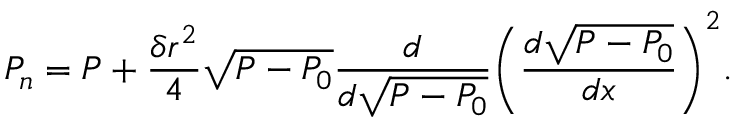Convert formula to latex. <formula><loc_0><loc_0><loc_500><loc_500>P _ { n } = P + \frac { \delta r ^ { 2 } } { 4 } \sqrt { P - P _ { 0 } } \frac { d } { d \sqrt { P - P _ { 0 } } } { \left ( \frac { d \sqrt { P - P _ { 0 } } } { d x } \right ) } ^ { 2 } .</formula> 